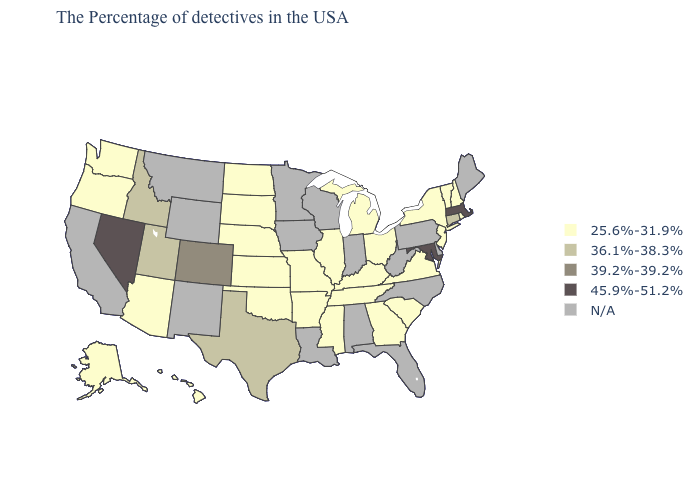Does Massachusetts have the lowest value in the Northeast?
Give a very brief answer. No. What is the value of Idaho?
Be succinct. 36.1%-38.3%. Name the states that have a value in the range 36.1%-38.3%?
Concise answer only. Connecticut, Texas, Utah, Idaho. What is the value of Pennsylvania?
Concise answer only. N/A. Name the states that have a value in the range 45.9%-51.2%?
Be succinct. Massachusetts, Maryland, Nevada. Which states hav the highest value in the South?
Be succinct. Maryland. What is the highest value in the South ?
Write a very short answer. 45.9%-51.2%. What is the highest value in states that border Tennessee?
Keep it brief. 25.6%-31.9%. What is the lowest value in the MidWest?
Concise answer only. 25.6%-31.9%. What is the lowest value in the USA?
Answer briefly. 25.6%-31.9%. Does the map have missing data?
Short answer required. Yes. What is the value of Georgia?
Short answer required. 25.6%-31.9%. What is the lowest value in the West?
Quick response, please. 25.6%-31.9%. What is the value of Arizona?
Keep it brief. 25.6%-31.9%. 